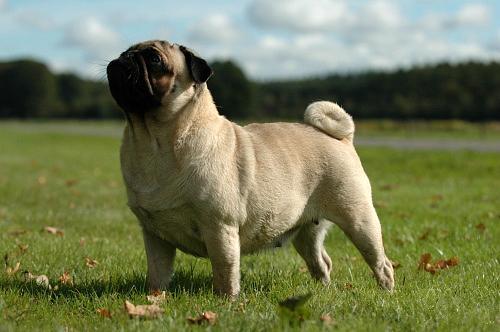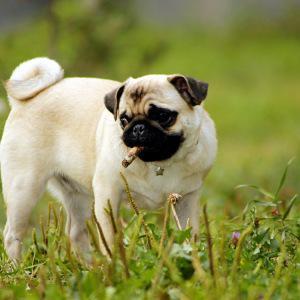The first image is the image on the left, the second image is the image on the right. Evaluate the accuracy of this statement regarding the images: "A small dark-faced dog has a stick in its mouth and is standing in a field.". Is it true? Answer yes or no. Yes. 